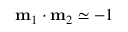<formula> <loc_0><loc_0><loc_500><loc_500>m _ { 1 } \cdot m _ { 2 } \simeq - 1</formula> 